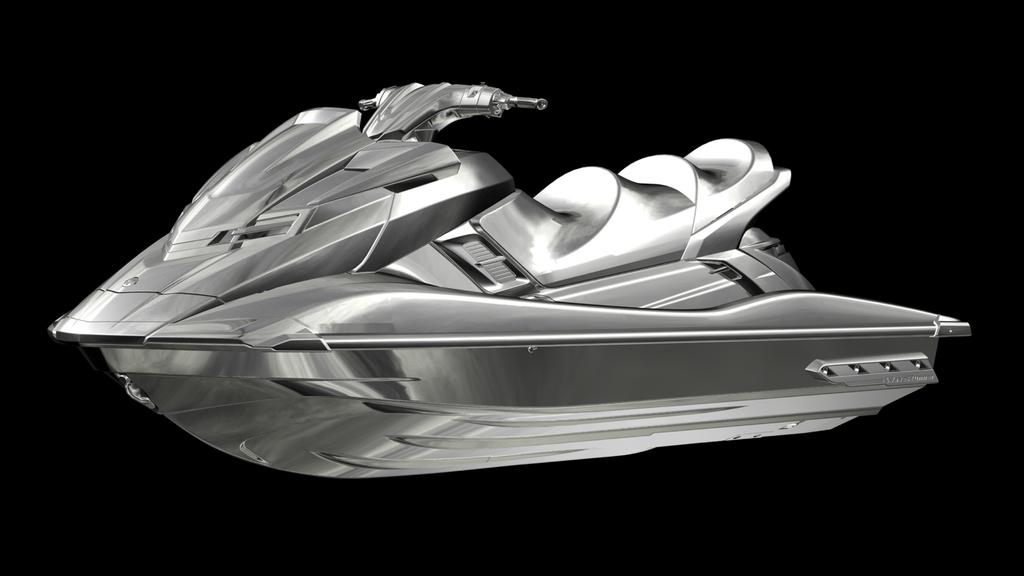What type of vehicle is in the image? There is a silver color motorboat in the image. What feature does the motorboat have? The motorboat has a handle. What color is the background of the image? The background of the image is black. How many girls are walking with the fowl in the image? There are no girls or fowl present in the image; it features a silver color motorboat with a handle against a black background. 